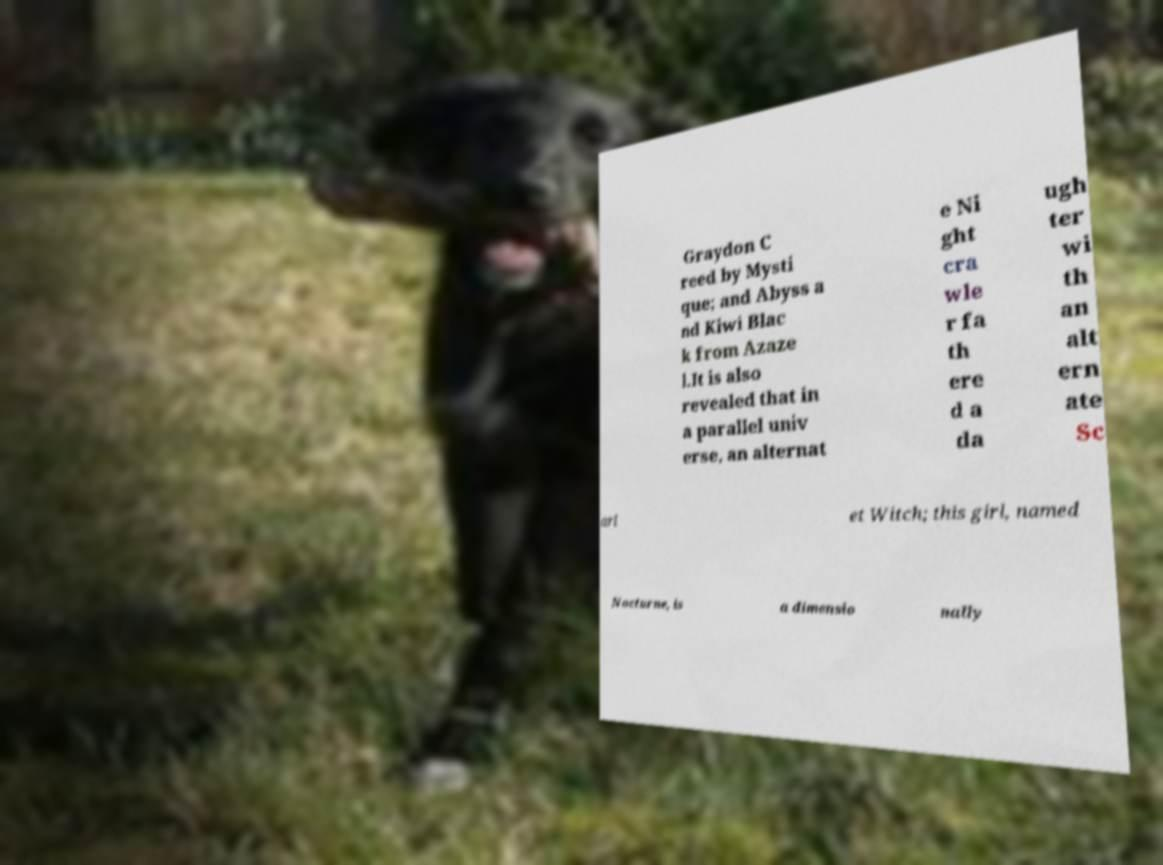Could you assist in decoding the text presented in this image and type it out clearly? Graydon C reed by Mysti que; and Abyss a nd Kiwi Blac k from Azaze l.It is also revealed that in a parallel univ erse, an alternat e Ni ght cra wle r fa th ere d a da ugh ter wi th an alt ern ate Sc arl et Witch; this girl, named Nocturne, is a dimensio nally 